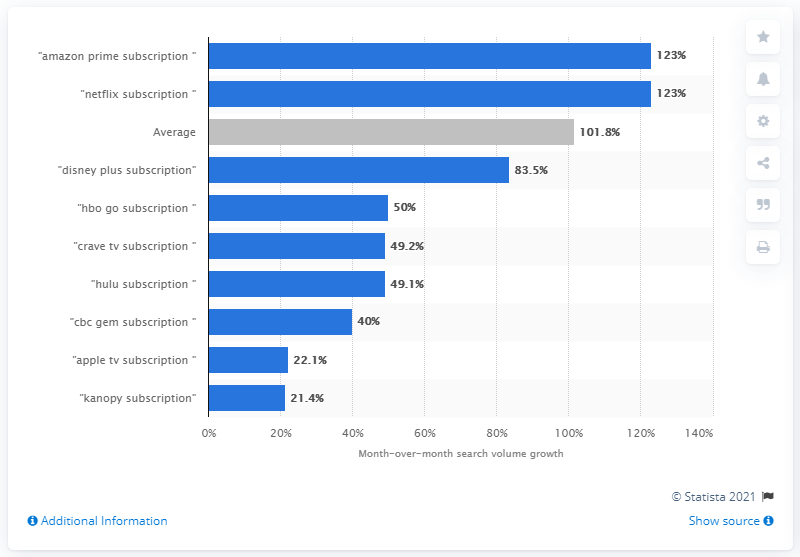List a handful of essential elements in this visual. The number of online searches for "Netflix + subscription" between February and March 2020 increased by 123. 